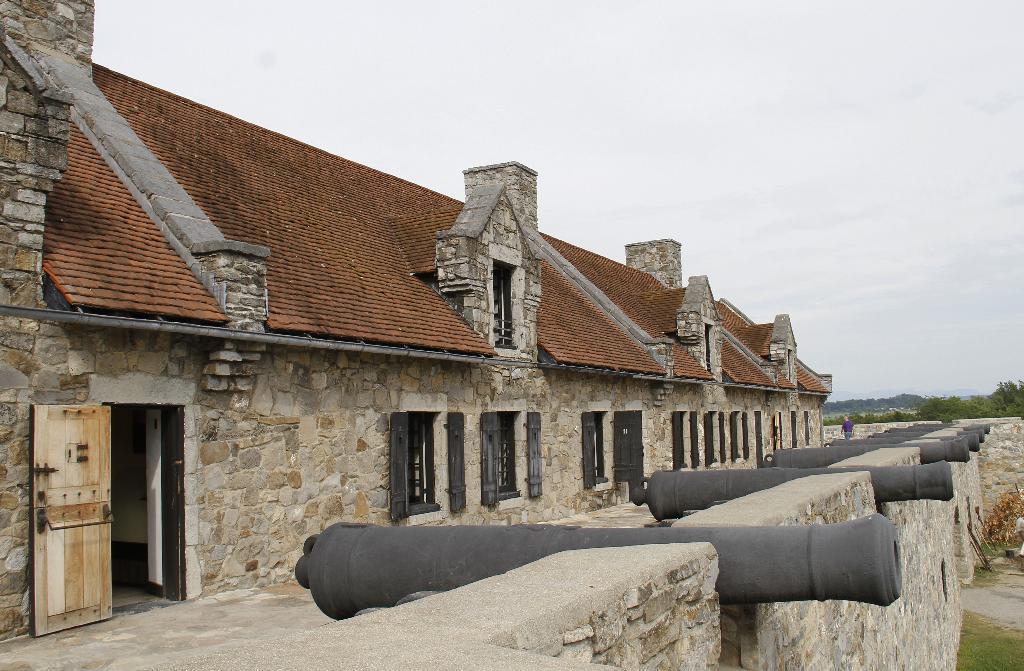How would you summarize this image in a sentence or two? This picture shows buildings and we see trees and a cloudy sky and grass on the ground and a wooden door. 